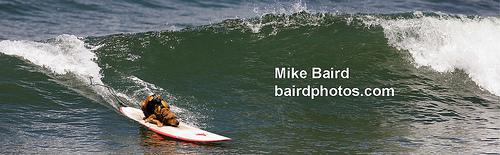Question: what is the color of the water?
Choices:
A. Blue.
B. Blue green.
C. Sea green.
D. Ultramarine blue.
Answer with the letter. Answer: B Question: who is on the surfboard?
Choices:
A. A man.
B. The dog.
C. A woman.
D. A child.
Answer with the letter. Answer: B Question: where is the dog?
Choices:
A. On the sofa.
B. On the chair.
C. On the box.
D. On the surfing board.
Answer with the letter. Answer: D 